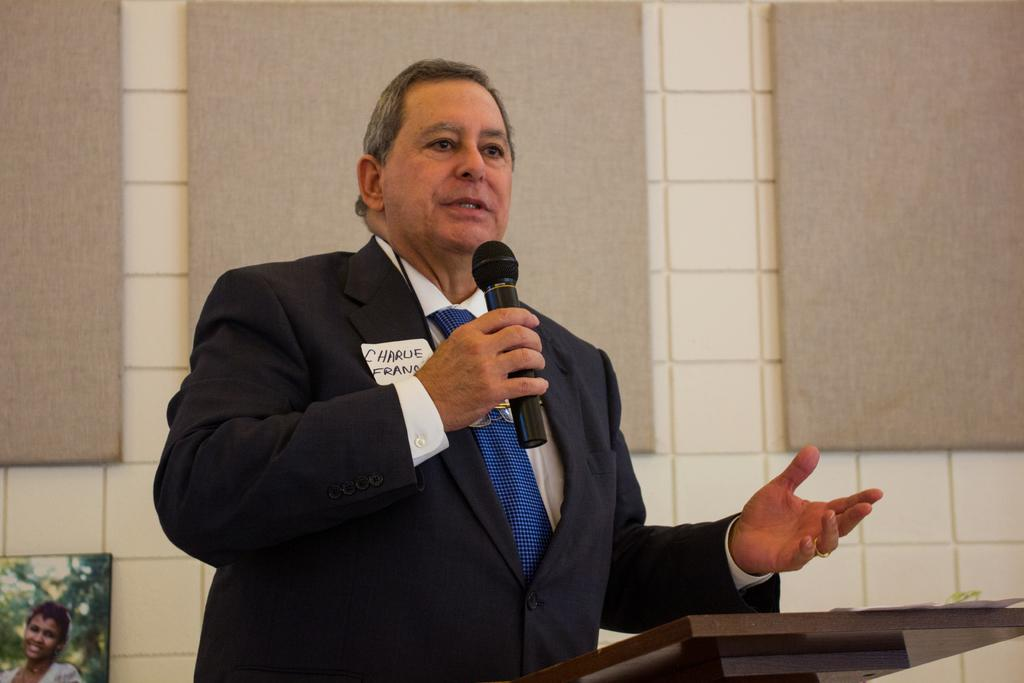What is the person in the image doing? The person is standing and talking in the image. What object is the person holding? The person is holding a microphone. What can be seen in the background of the image? There is a wall in the background of the image. What is the person standing behind in the image? There is a podium in the image. How many dinosaurs are visible in the image? There are no dinosaurs present in the image. 